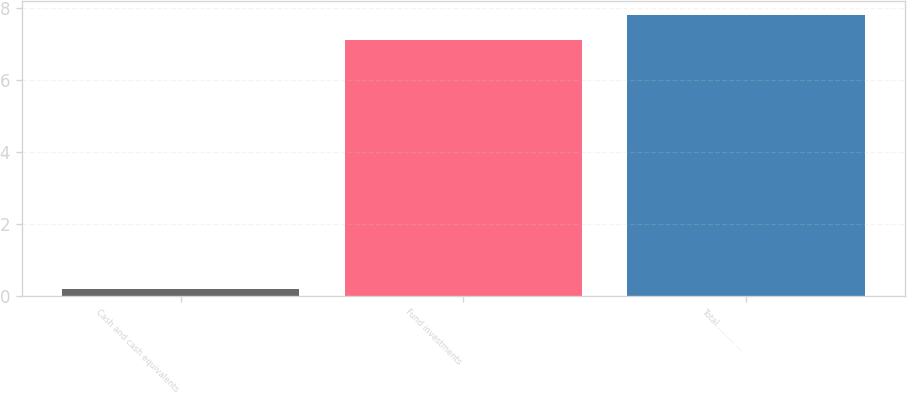Convert chart to OTSL. <chart><loc_0><loc_0><loc_500><loc_500><bar_chart><fcel>Cash and cash equivalents<fcel>Fund investments<fcel>Total……… …<nl><fcel>0.2<fcel>7.1<fcel>7.81<nl></chart> 